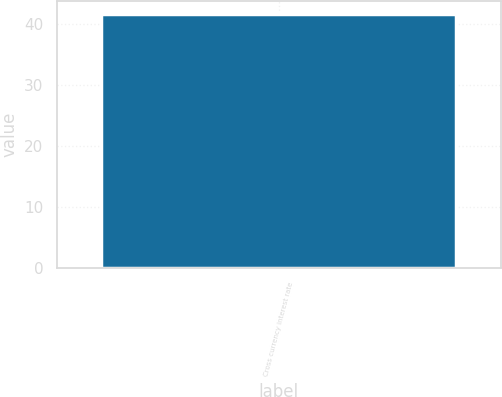Convert chart to OTSL. <chart><loc_0><loc_0><loc_500><loc_500><bar_chart><fcel>Cross currency interest rate<nl><fcel>41.6<nl></chart> 